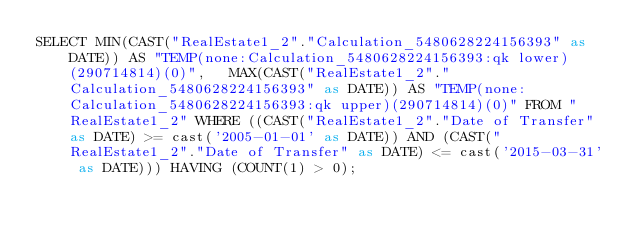Convert code to text. <code><loc_0><loc_0><loc_500><loc_500><_SQL_>SELECT MIN(CAST("RealEstate1_2"."Calculation_5480628224156393" as DATE)) AS "TEMP(none:Calculation_5480628224156393:qk lower)(290714814)(0)",   MAX(CAST("RealEstate1_2"."Calculation_5480628224156393" as DATE)) AS "TEMP(none:Calculation_5480628224156393:qk upper)(290714814)(0)" FROM "RealEstate1_2" WHERE ((CAST("RealEstate1_2"."Date of Transfer" as DATE) >= cast('2005-01-01' as DATE)) AND (CAST("RealEstate1_2"."Date of Transfer" as DATE) <= cast('2015-03-31' as DATE))) HAVING (COUNT(1) > 0);
</code> 